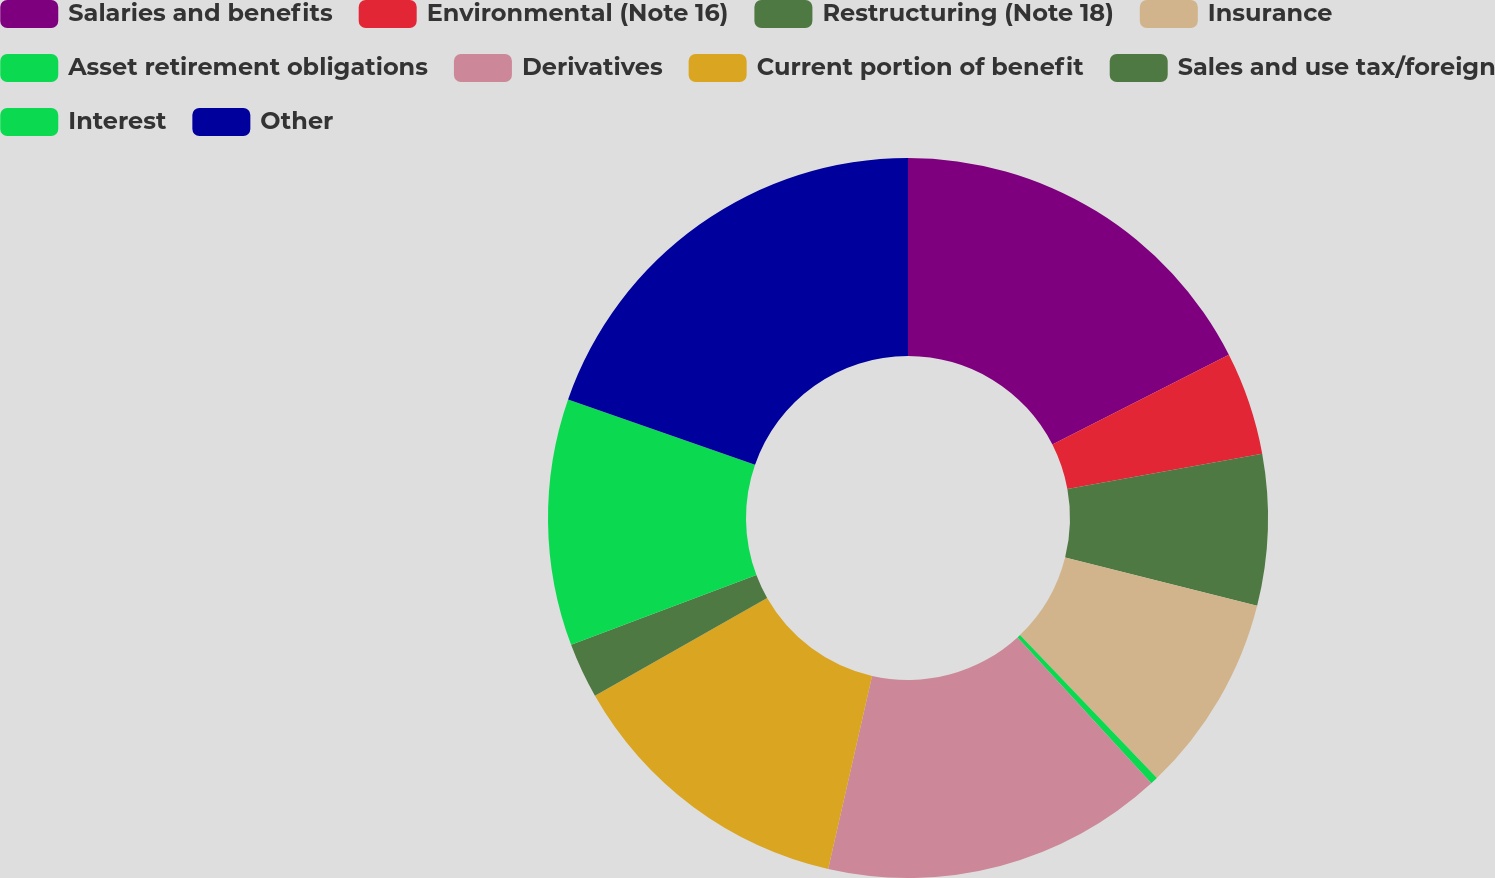Convert chart. <chart><loc_0><loc_0><loc_500><loc_500><pie_chart><fcel>Salaries and benefits<fcel>Environmental (Note 16)<fcel>Restructuring (Note 18)<fcel>Insurance<fcel>Asset retirement obligations<fcel>Derivatives<fcel>Current portion of benefit<fcel>Sales and use tax/foreign<fcel>Interest<fcel>Other<nl><fcel>17.51%<fcel>4.63%<fcel>6.78%<fcel>8.93%<fcel>0.34%<fcel>15.37%<fcel>13.22%<fcel>2.49%<fcel>11.07%<fcel>19.66%<nl></chart> 